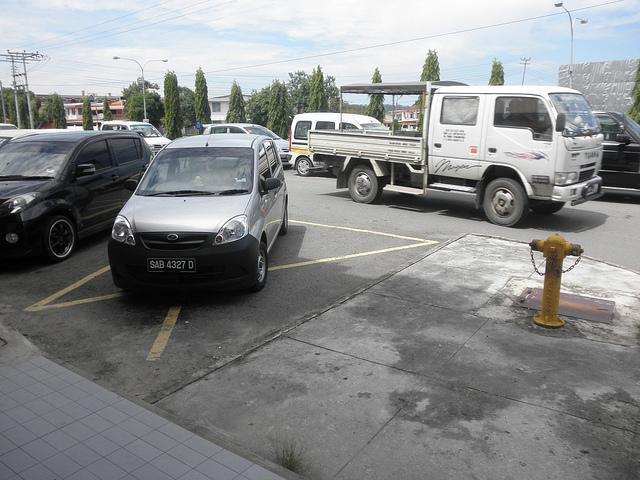Which car has violated the law?
From the following set of four choices, select the accurate answer to respond to the question.
Options: Silver car, white car, grey car, black car. Silver car. 